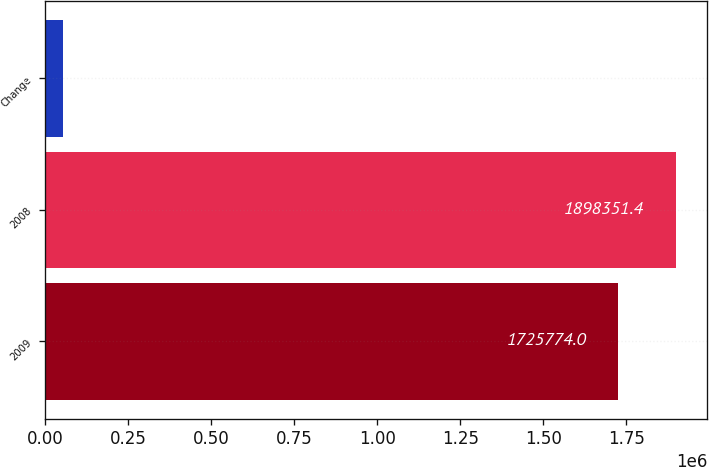<chart> <loc_0><loc_0><loc_500><loc_500><bar_chart><fcel>2009<fcel>2008<fcel>Change<nl><fcel>1.72577e+06<fcel>1.89835e+06<fcel>52409<nl></chart> 